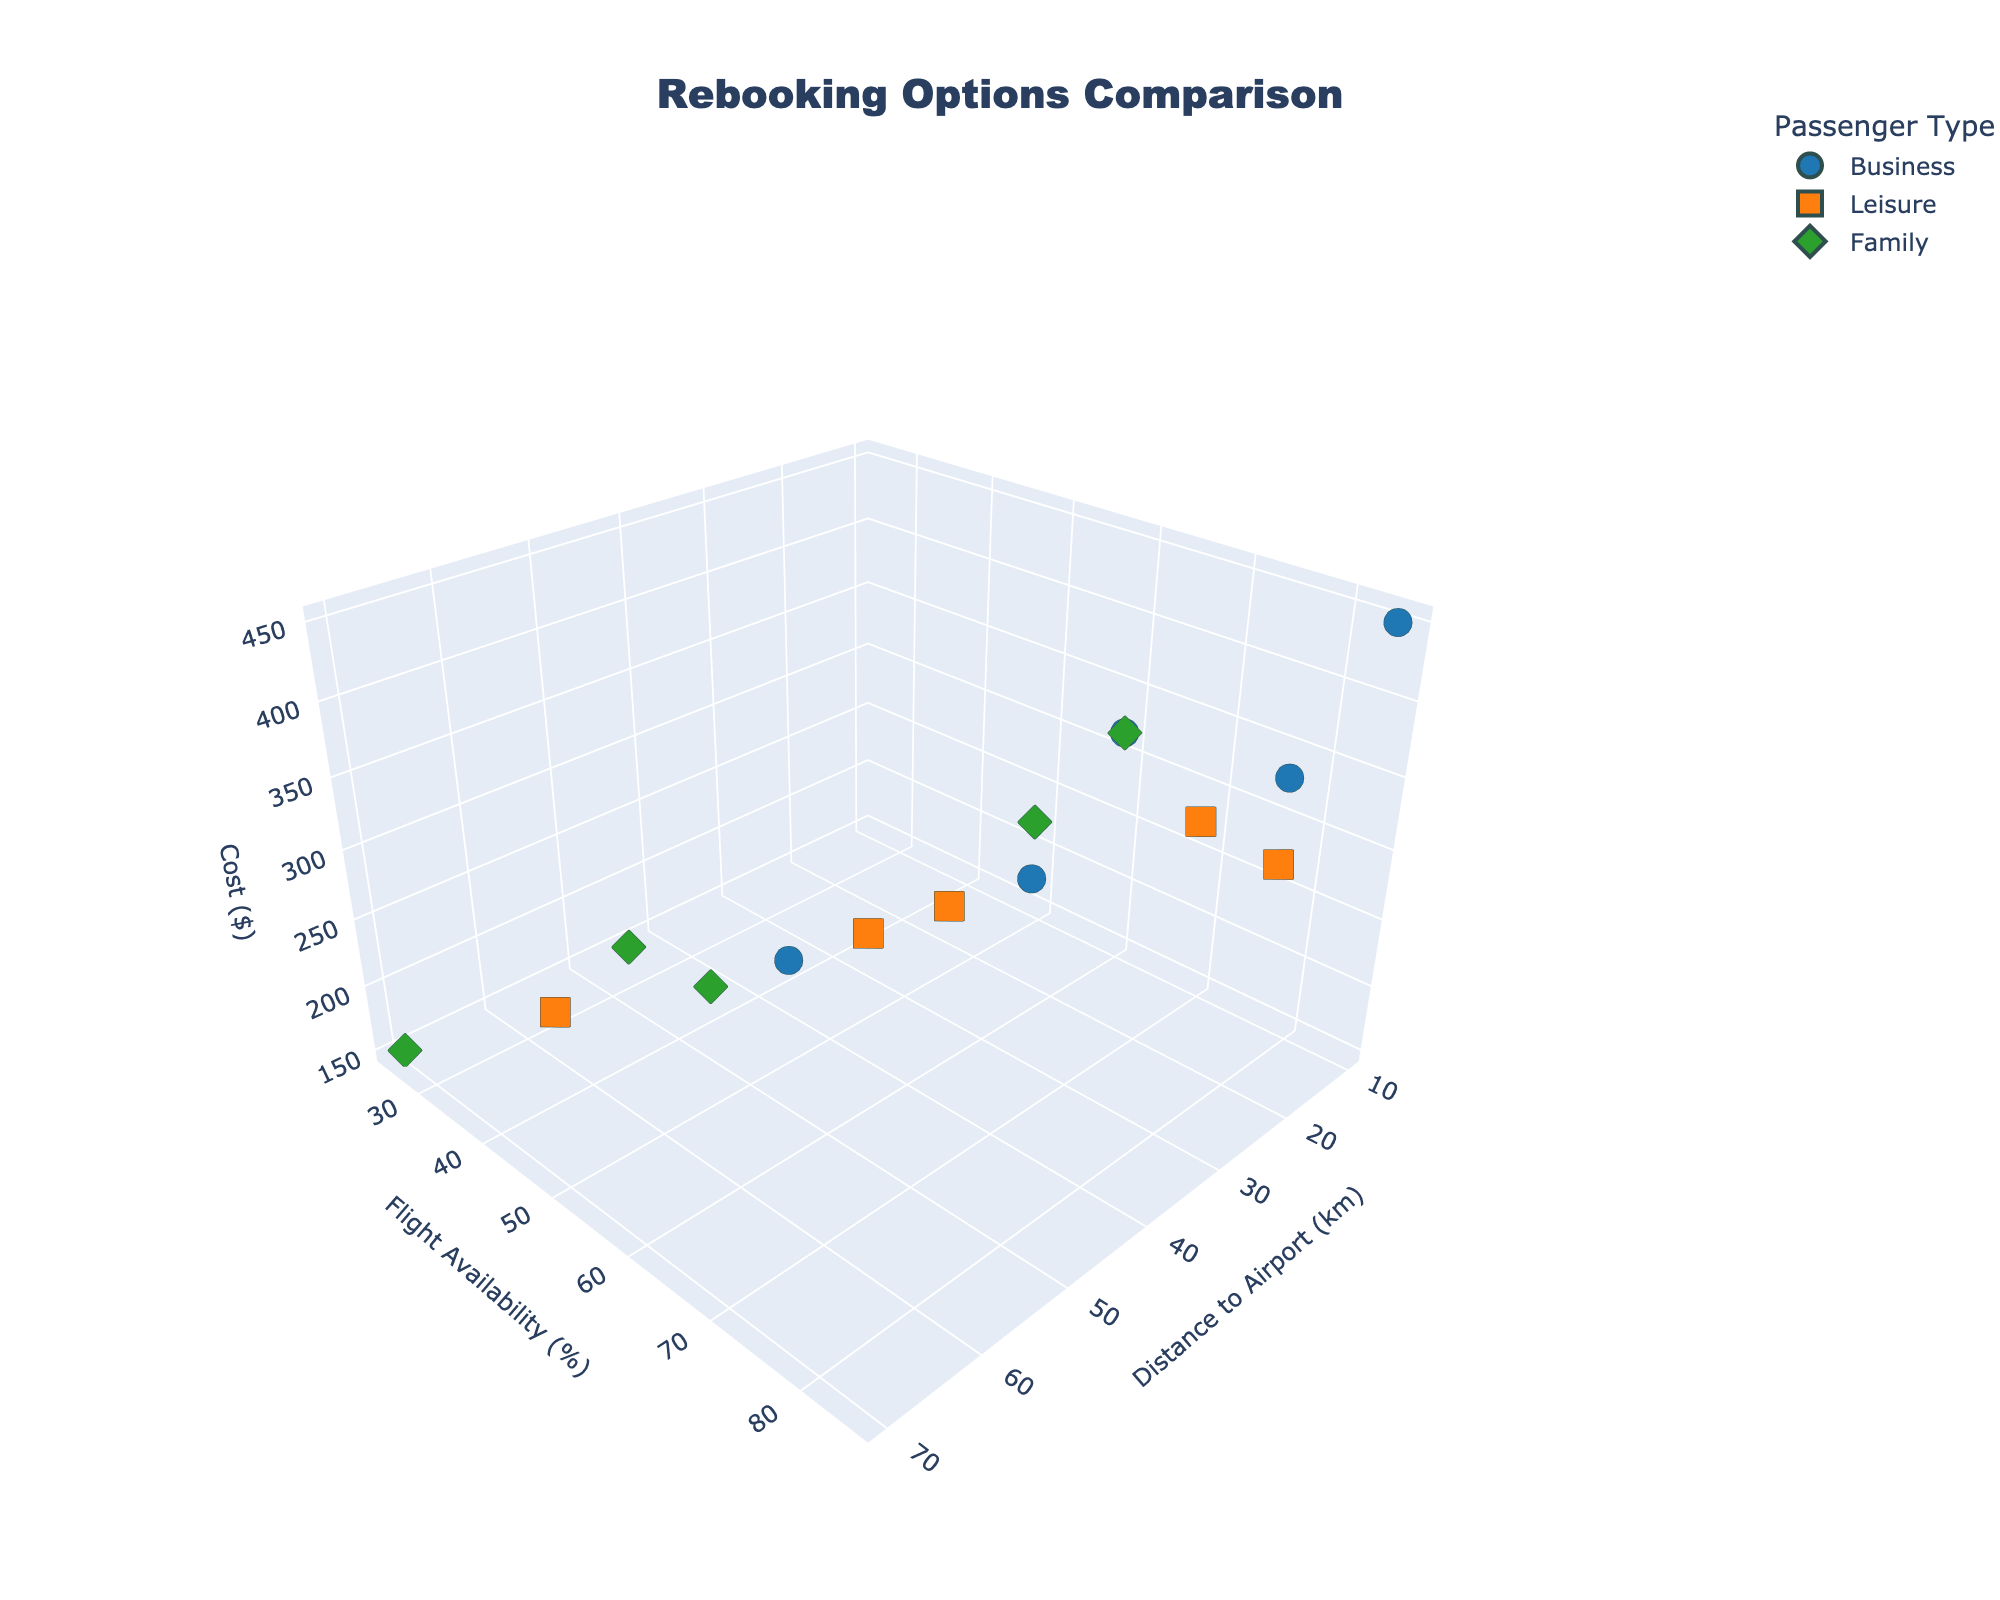What is the title of the plot? The title of the plot is usually positioned at the top of the figure.
Answer: Rebooking Options Comparison How many passenger types are there in the plot? There are three different colors and symbols representing the passenger types in the plot: circles for Business, squares for Leisure, and diamonds for Family.
Answer: 3 Which passenger type has the highest cost outlier? The outlier with the highest cost can be identified by finding the data point with the maximum value on the cost (z) axis. This point is a circle, indicating it belongs to the Business passenger type.
Answer: Business Which passenger type generally has the lowest flight availability? By examining the y-axis (Flight Availability) values, the lowest cluster of flight availability points is mostly green diamonds, representing Family passengers.
Answer: Family What is the average cost for Leisure passengers? Sum up the cost values for Leisure passengers (320, 240, 180, 290, 260) and divide by the number of points (5). Calculation: (320 + 240 + 180 + 290 + 260)/5 = 1290/5
Answer: 258 Which passenger type has the widest range of flight availability? Find the range for each type by subtracting the minimum flight availability from the maximum for each passenger type. Business: 85 - 50 = 35, Leisure: 80 - 35 = 45, Family: 70 - 25 = 45. Leisure and Family both have a range of 45%.
Answer: Leisure and Family What is the maximum distance to the airport for any Business passenger? Identify the highest value on the Distance_to_Airport axis for Business points (blue circles) by looking at the furthest point on the x-axis for that category.
Answer: 45 km Are there any Leisure passengers with a flight availability above 80%? Check if there are any orange square points above the 80% mark on the y-axis. There is one point at 80%.
Answer: Yes Which passenger type has an average distance to the airport closest to 30 km? Calculate the average distance for each passenger type and compare. Business: (15 + 30 + 45 + 10 + 25)/5 = 25, Leisure: (20 + 40 + 60 + 15 + 35)/5 = 34, Family: (50 + 30 + 70 + 25 + 55)/5 = 46, thus Business is closest to 30 km.
Answer: Business 